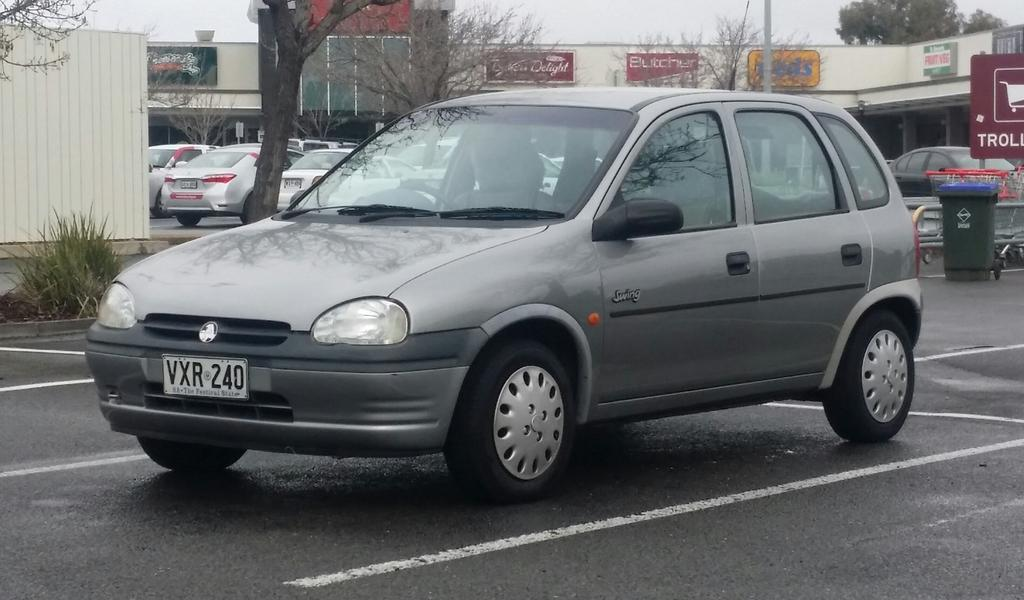What can be seen on the road in the image? There are vehicles on the road in the image. What object is present for waste disposal? There is a bin in the image. What type of vegetation is visible in the image? There are trees and plants in the image. What structures are present in the image? There are boards, poles, and a building in the image. What part of the natural environment is visible in the image? The sky is visible in the image. What theory is being discussed by the vehicles on the road in the image? There is no discussion or theory present in the image; it simply shows vehicles on the road. Can you tell me how many doors are visible on the building in the image? There is no door visible on the building in the image. 